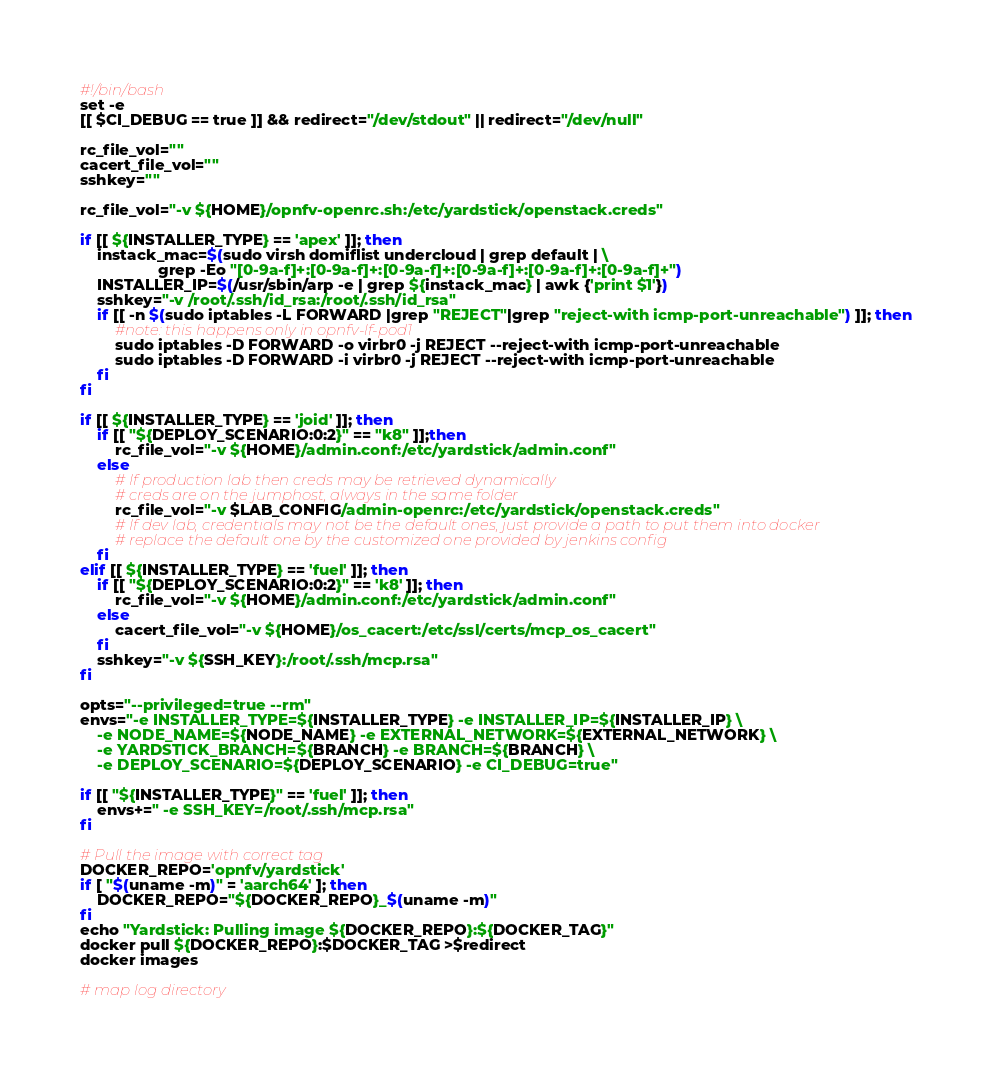<code> <loc_0><loc_0><loc_500><loc_500><_Bash_>#!/bin/bash
set -e
[[ $CI_DEBUG == true ]] && redirect="/dev/stdout" || redirect="/dev/null"

rc_file_vol=""
cacert_file_vol=""
sshkey=""

rc_file_vol="-v ${HOME}/opnfv-openrc.sh:/etc/yardstick/openstack.creds"

if [[ ${INSTALLER_TYPE} == 'apex' ]]; then
    instack_mac=$(sudo virsh domiflist undercloud | grep default | \
                  grep -Eo "[0-9a-f]+:[0-9a-f]+:[0-9a-f]+:[0-9a-f]+:[0-9a-f]+:[0-9a-f]+")
    INSTALLER_IP=$(/usr/sbin/arp -e | grep ${instack_mac} | awk {'print $1'})
    sshkey="-v /root/.ssh/id_rsa:/root/.ssh/id_rsa"
    if [[ -n $(sudo iptables -L FORWARD |grep "REJECT"|grep "reject-with icmp-port-unreachable") ]]; then
        #note: this happens only in opnfv-lf-pod1
        sudo iptables -D FORWARD -o virbr0 -j REJECT --reject-with icmp-port-unreachable
        sudo iptables -D FORWARD -i virbr0 -j REJECT --reject-with icmp-port-unreachable
    fi
fi

if [[ ${INSTALLER_TYPE} == 'joid' ]]; then
    if [[ "${DEPLOY_SCENARIO:0:2}" == "k8" ]];then
        rc_file_vol="-v ${HOME}/admin.conf:/etc/yardstick/admin.conf"
    else
        # If production lab then creds may be retrieved dynamically
        # creds are on the jumphost, always in the same folder
        rc_file_vol="-v $LAB_CONFIG/admin-openrc:/etc/yardstick/openstack.creds"
        # If dev lab, credentials may not be the default ones, just provide a path to put them into docker
        # replace the default one by the customized one provided by jenkins config
    fi
elif [[ ${INSTALLER_TYPE} == 'fuel' ]]; then
    if [[ "${DEPLOY_SCENARIO:0:2}" == 'k8' ]]; then
        rc_file_vol="-v ${HOME}/admin.conf:/etc/yardstick/admin.conf"
    else
        cacert_file_vol="-v ${HOME}/os_cacert:/etc/ssl/certs/mcp_os_cacert"
    fi
    sshkey="-v ${SSH_KEY}:/root/.ssh/mcp.rsa"
fi

opts="--privileged=true --rm"
envs="-e INSTALLER_TYPE=${INSTALLER_TYPE} -e INSTALLER_IP=${INSTALLER_IP} \
    -e NODE_NAME=${NODE_NAME} -e EXTERNAL_NETWORK=${EXTERNAL_NETWORK} \
    -e YARDSTICK_BRANCH=${BRANCH} -e BRANCH=${BRANCH} \
    -e DEPLOY_SCENARIO=${DEPLOY_SCENARIO} -e CI_DEBUG=true"

if [[ "${INSTALLER_TYPE}" == 'fuel' ]]; then
    envs+=" -e SSH_KEY=/root/.ssh/mcp.rsa"
fi

# Pull the image with correct tag
DOCKER_REPO='opnfv/yardstick'
if [ "$(uname -m)" = 'aarch64' ]; then
    DOCKER_REPO="${DOCKER_REPO}_$(uname -m)"
fi
echo "Yardstick: Pulling image ${DOCKER_REPO}:${DOCKER_TAG}"
docker pull ${DOCKER_REPO}:$DOCKER_TAG >$redirect
docker images

# map log directory</code> 